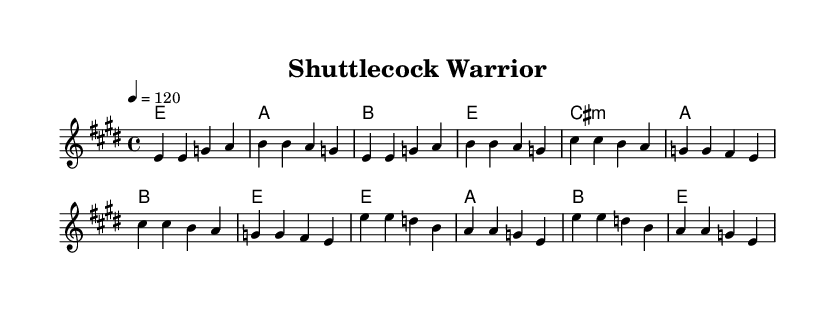What is the key signature of this music? The key signature is indicated by the sharp symbols at the beginning of the staff. This piece is in E major, which has four sharps: F#, C#, G#, and D#.
Answer: E major What is the time signature of this music? The time signature is shown at the beginning of the score, indicating how many beats are in each measure. This piece has a time signature of 4/4, meaning there are four beats per measure.
Answer: 4/4 What is the tempo indication for this piece? The tempo is noted at the beginning of the score with a metronome marking. It indicates that the piece should be played at a speed of 120 beats per minute.
Answer: 120 How many sections are there in this piece? The sections can be identified in the structure of the lyrics and melody. The piece consists of three identifiable sections: Verse, Pre-Chorus, and Chorus.
Answer: Three What is the primary theme expressed in the chorus? The chorus emphasizes determination and resilience, as indicated by the lyrics expressing rising high and overcoming challenges. This theme is common in rock anthems that celebrate personal strength.
Answer: Resilience What chord follows the first verse? The chord progression suggests that after the first verse, the piece transitions to an A major chord, as indicated in the harmony part of the sheet music.
Answer: A What is the characteristic of the lyrics in the pre-chorus? The pre-chorus lyrics contain a sense of personal struggle and motivation, reflecting the challenge faced by the speaker, which aligns with the thematic elements of classic rock anthems.
Answer: Motivation 